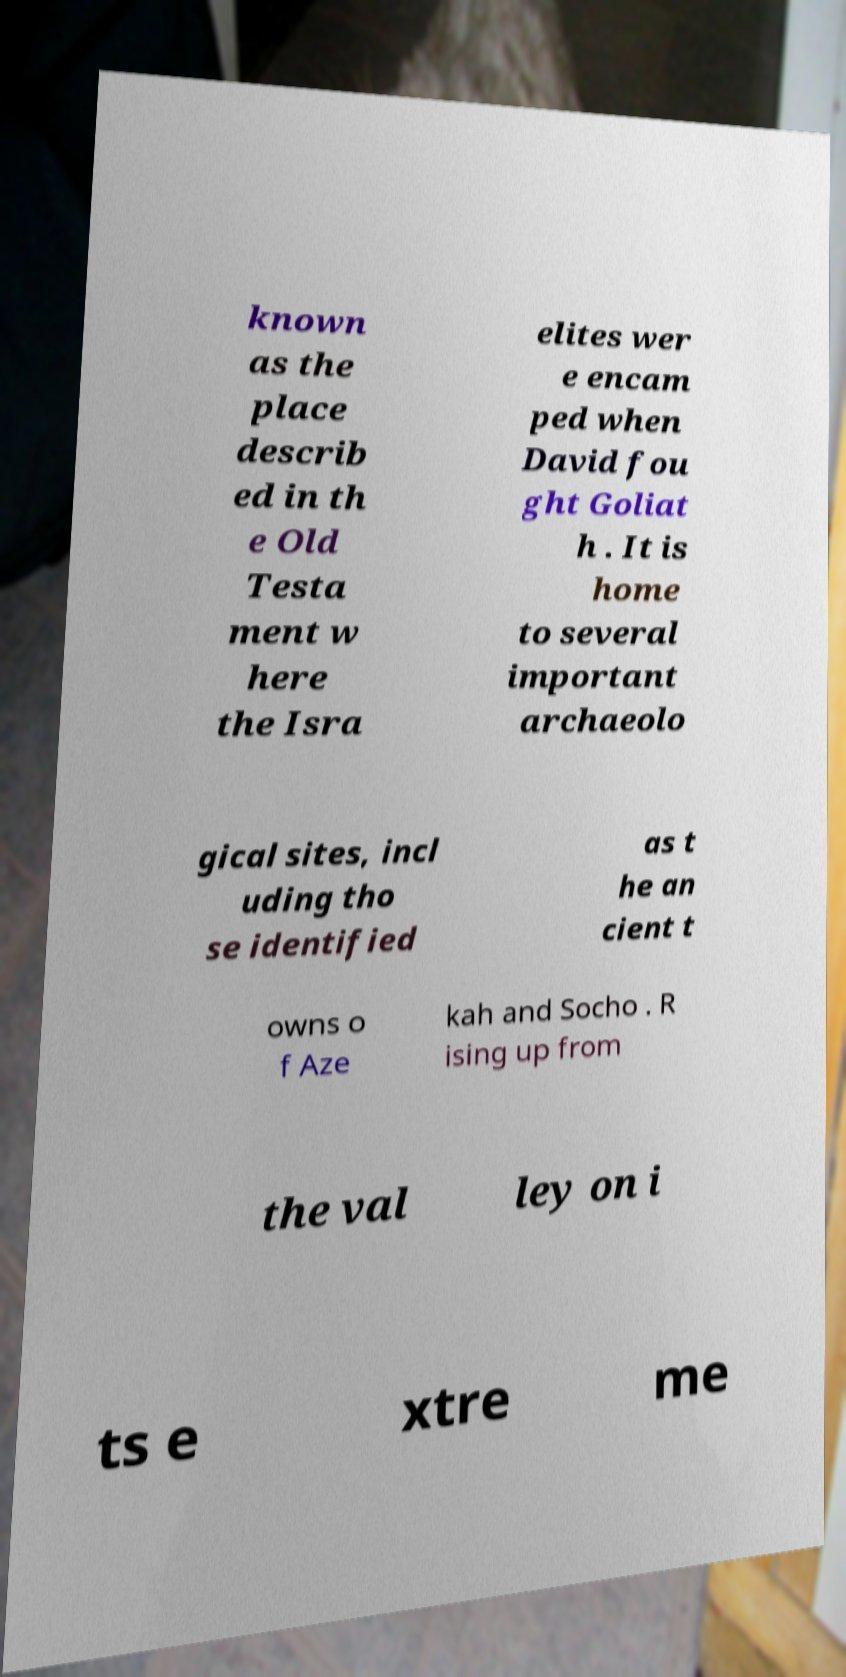Could you assist in decoding the text presented in this image and type it out clearly? known as the place describ ed in th e Old Testa ment w here the Isra elites wer e encam ped when David fou ght Goliat h . It is home to several important archaeolo gical sites, incl uding tho se identified as t he an cient t owns o f Aze kah and Socho . R ising up from the val ley on i ts e xtre me 